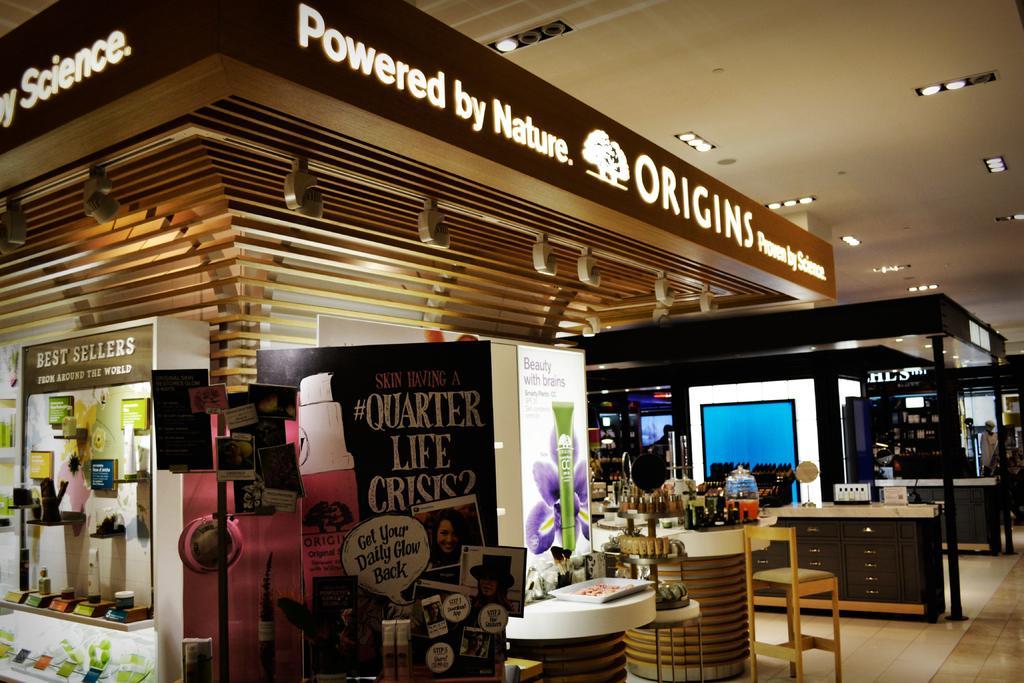Describe this image in one or two sentences. This image is clicked inside a mall, on the top there are ceiling lights, on the left side it seems to be a store with table and chairs in front of it with many things on it, on the left side there are some products on the shelf with a banner beside it. 